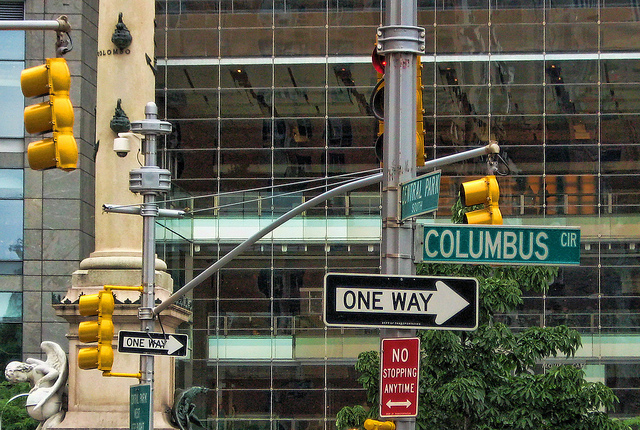<image>What city is this photo taken in? I am not sure. This photo might be taken in either New York or Columbus. What city is this photo taken in? I am not sure what city this photo is taken in. It can be either New York or Columbus. 